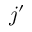<formula> <loc_0><loc_0><loc_500><loc_500>j ^ { \prime }</formula> 